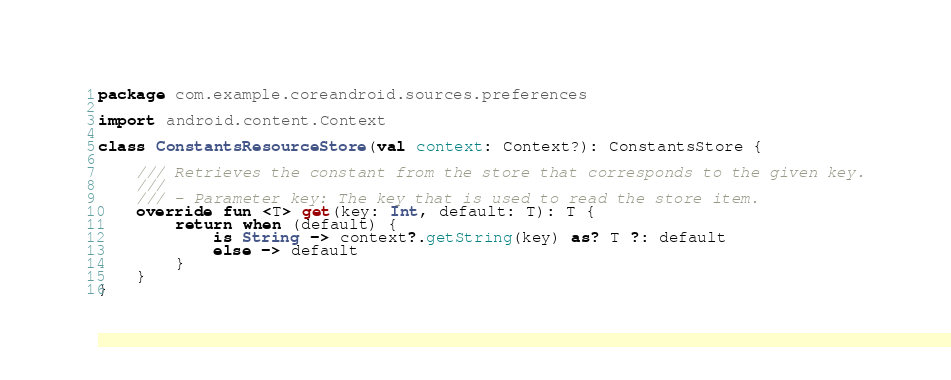<code> <loc_0><loc_0><loc_500><loc_500><_Kotlin_>package com.example.coreandroid.sources.preferences

import android.content.Context

class ConstantsResourceStore(val context: Context?): ConstantsStore {

    /// Retrieves the constant from the store that corresponds to the given key.
    ///
    /// - Parameter key: The key that is used to read the store item.
    override fun <T> get(key: Int, default: T): T {
        return when (default) {
            is String -> context?.getString(key) as? T ?: default
            else -> default
        }
    }
}</code> 